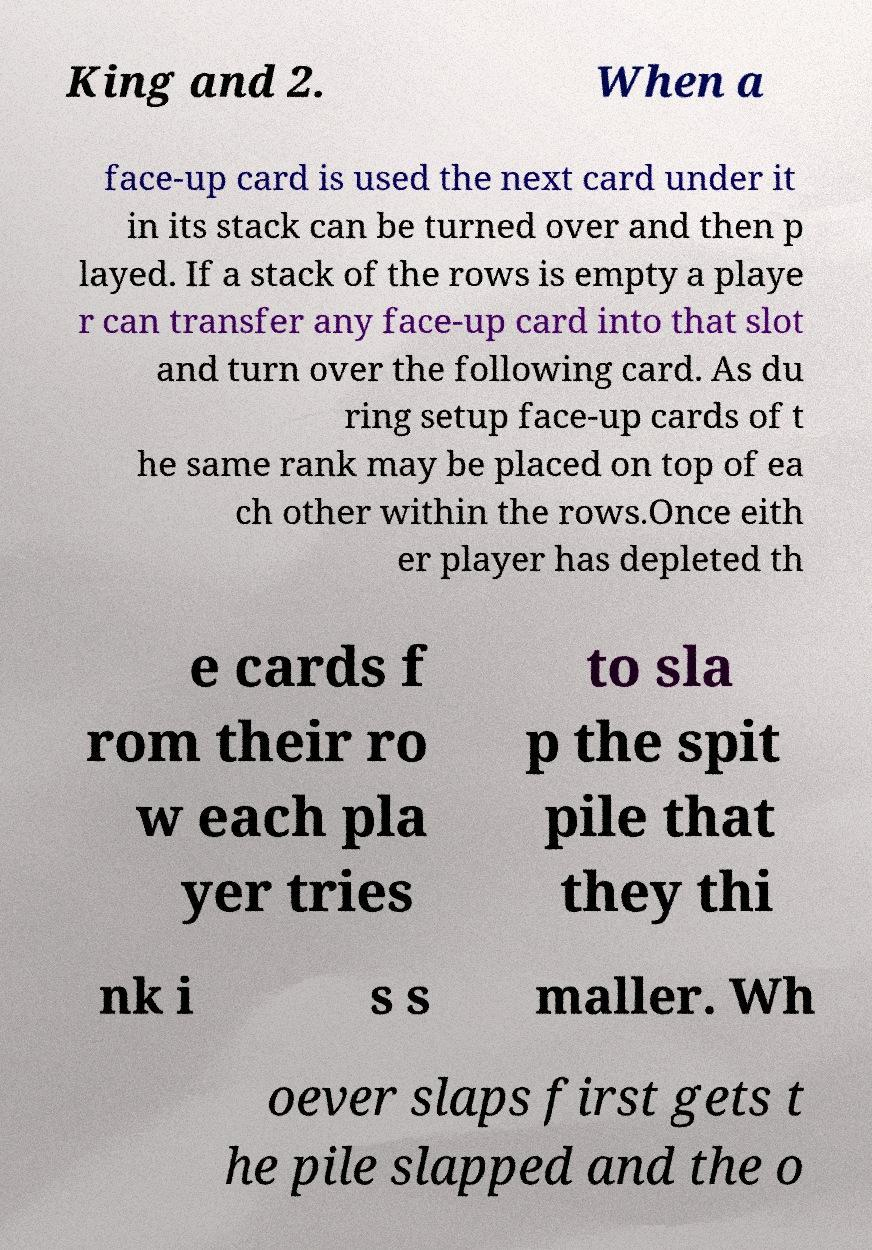Can you read and provide the text displayed in the image?This photo seems to have some interesting text. Can you extract and type it out for me? King and 2. When a face-up card is used the next card under it in its stack can be turned over and then p layed. If a stack of the rows is empty a playe r can transfer any face-up card into that slot and turn over the following card. As du ring setup face-up cards of t he same rank may be placed on top of ea ch other within the rows.Once eith er player has depleted th e cards f rom their ro w each pla yer tries to sla p the spit pile that they thi nk i s s maller. Wh oever slaps first gets t he pile slapped and the o 